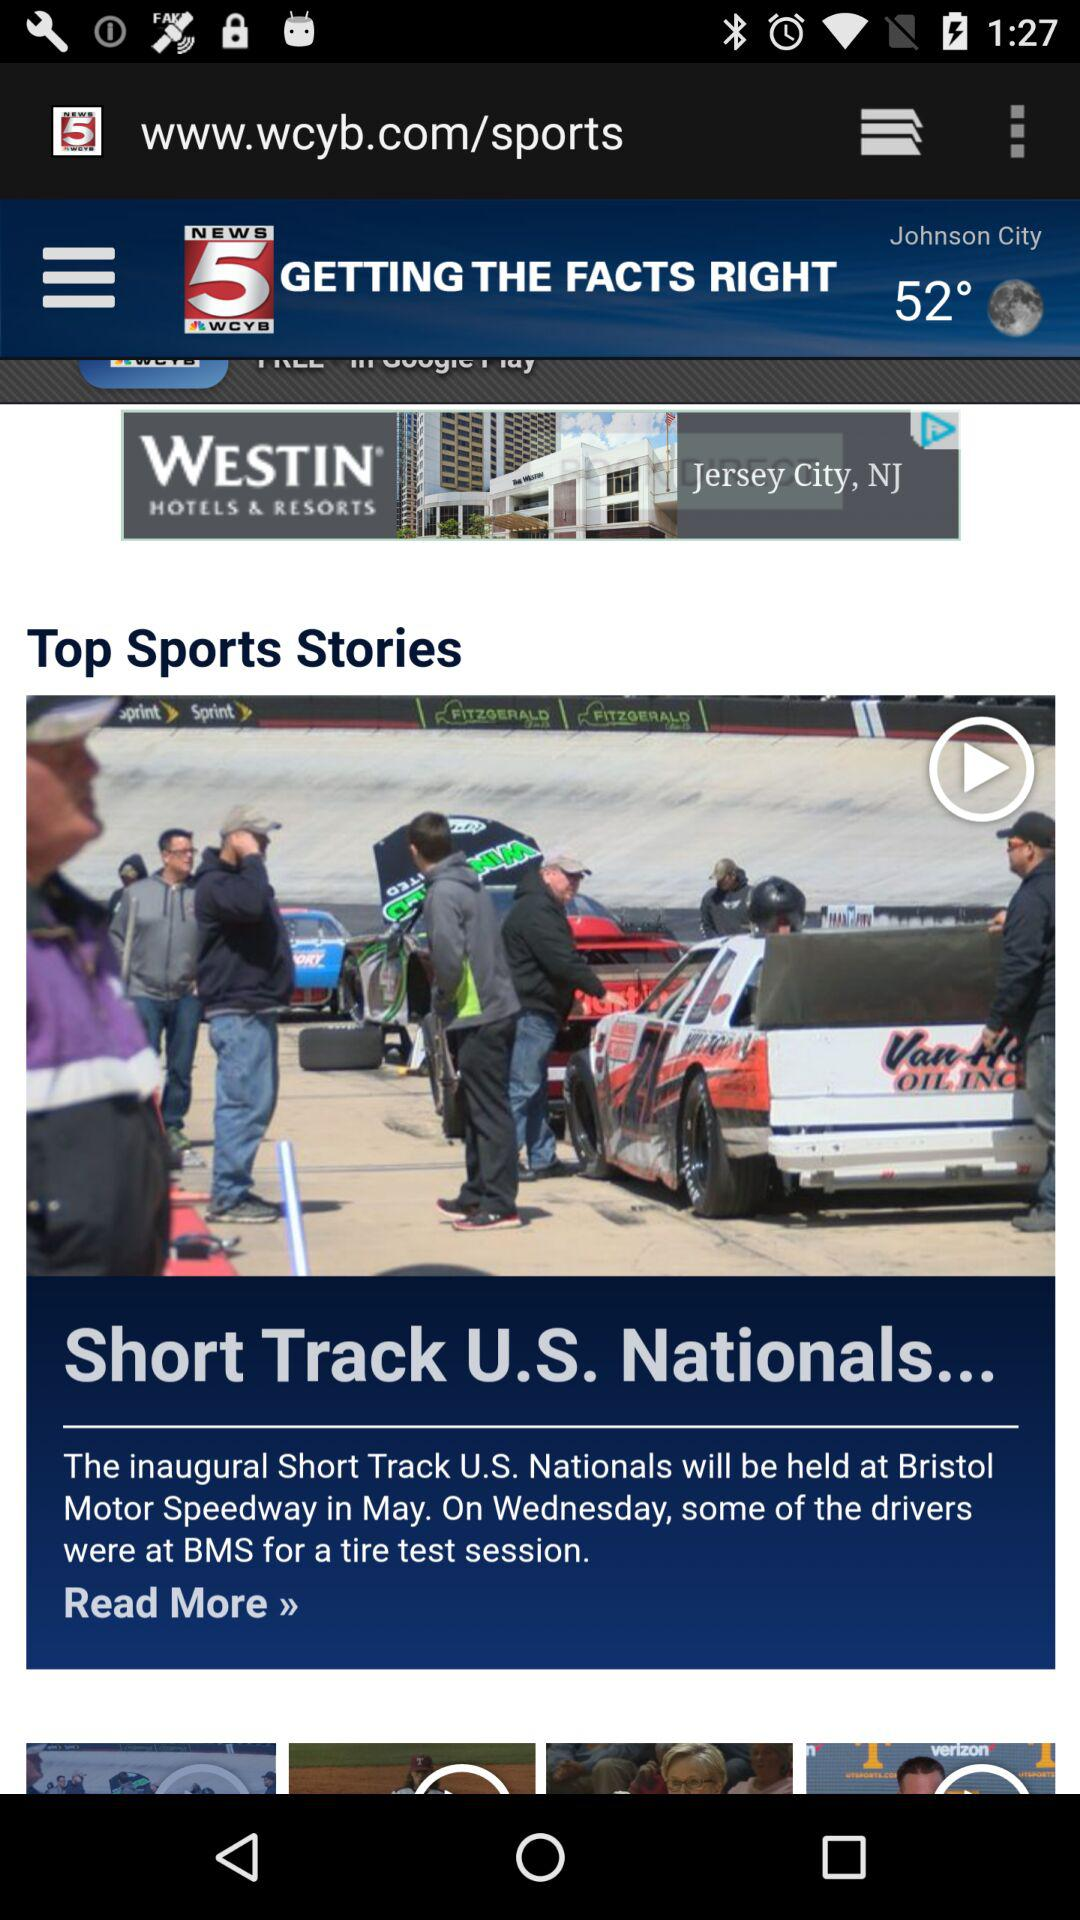On what day will the inaugural short track be held? The inaugural short track will be held on Wednesday. 